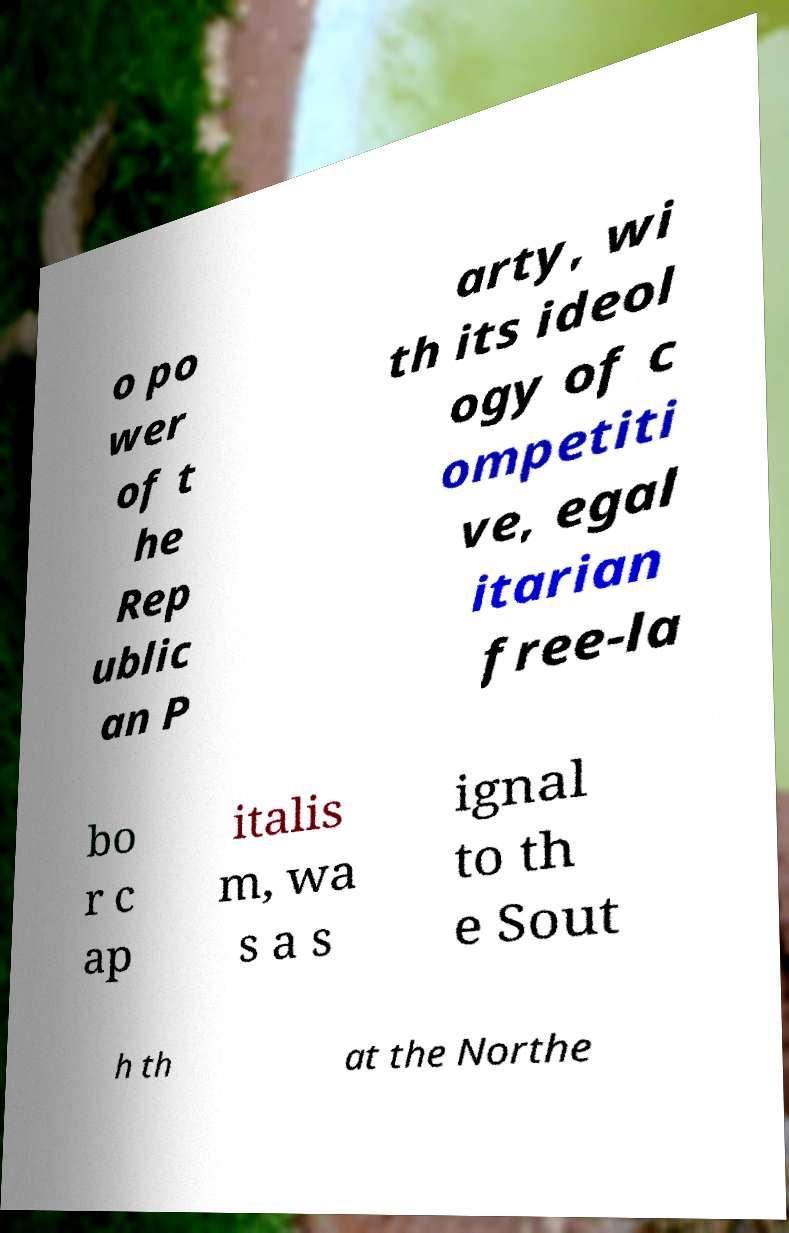I need the written content from this picture converted into text. Can you do that? o po wer of t he Rep ublic an P arty, wi th its ideol ogy of c ompetiti ve, egal itarian free-la bo r c ap italis m, wa s a s ignal to th e Sout h th at the Northe 